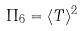Convert formula to latex. <formula><loc_0><loc_0><loc_500><loc_500>\Pi _ { 6 } = \langle T \rangle ^ { 2 }</formula> 